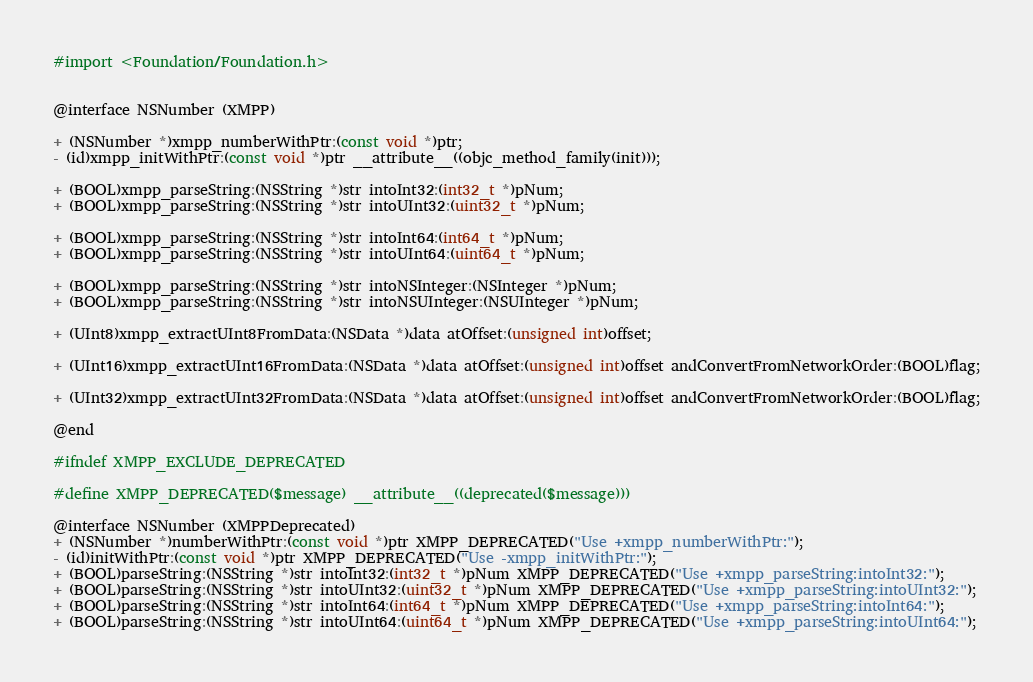<code> <loc_0><loc_0><loc_500><loc_500><_C_>#import <Foundation/Foundation.h>


@interface NSNumber (XMPP)

+ (NSNumber *)xmpp_numberWithPtr:(const void *)ptr;
- (id)xmpp_initWithPtr:(const void *)ptr __attribute__((objc_method_family(init)));

+ (BOOL)xmpp_parseString:(NSString *)str intoInt32:(int32_t *)pNum;
+ (BOOL)xmpp_parseString:(NSString *)str intoUInt32:(uint32_t *)pNum;

+ (BOOL)xmpp_parseString:(NSString *)str intoInt64:(int64_t *)pNum;
+ (BOOL)xmpp_parseString:(NSString *)str intoUInt64:(uint64_t *)pNum;

+ (BOOL)xmpp_parseString:(NSString *)str intoNSInteger:(NSInteger *)pNum;
+ (BOOL)xmpp_parseString:(NSString *)str intoNSUInteger:(NSUInteger *)pNum;

+ (UInt8)xmpp_extractUInt8FromData:(NSData *)data atOffset:(unsigned int)offset;

+ (UInt16)xmpp_extractUInt16FromData:(NSData *)data atOffset:(unsigned int)offset andConvertFromNetworkOrder:(BOOL)flag;

+ (UInt32)xmpp_extractUInt32FromData:(NSData *)data atOffset:(unsigned int)offset andConvertFromNetworkOrder:(BOOL)flag;

@end

#ifndef XMPP_EXCLUDE_DEPRECATED

#define XMPP_DEPRECATED($message) __attribute__((deprecated($message)))

@interface NSNumber (XMPPDeprecated)
+ (NSNumber *)numberWithPtr:(const void *)ptr XMPP_DEPRECATED("Use +xmpp_numberWithPtr:");
- (id)initWithPtr:(const void *)ptr XMPP_DEPRECATED("Use -xmpp_initWithPtr:");
+ (BOOL)parseString:(NSString *)str intoInt32:(int32_t *)pNum XMPP_DEPRECATED("Use +xmpp_parseString:intoInt32:");
+ (BOOL)parseString:(NSString *)str intoUInt32:(uint32_t *)pNum XMPP_DEPRECATED("Use +xmpp_parseString:intoUInt32:");
+ (BOOL)parseString:(NSString *)str intoInt64:(int64_t *)pNum XMPP_DEPRECATED("Use +xmpp_parseString:intoInt64:");
+ (BOOL)parseString:(NSString *)str intoUInt64:(uint64_t *)pNum XMPP_DEPRECATED("Use +xmpp_parseString:intoUInt64:");</code> 